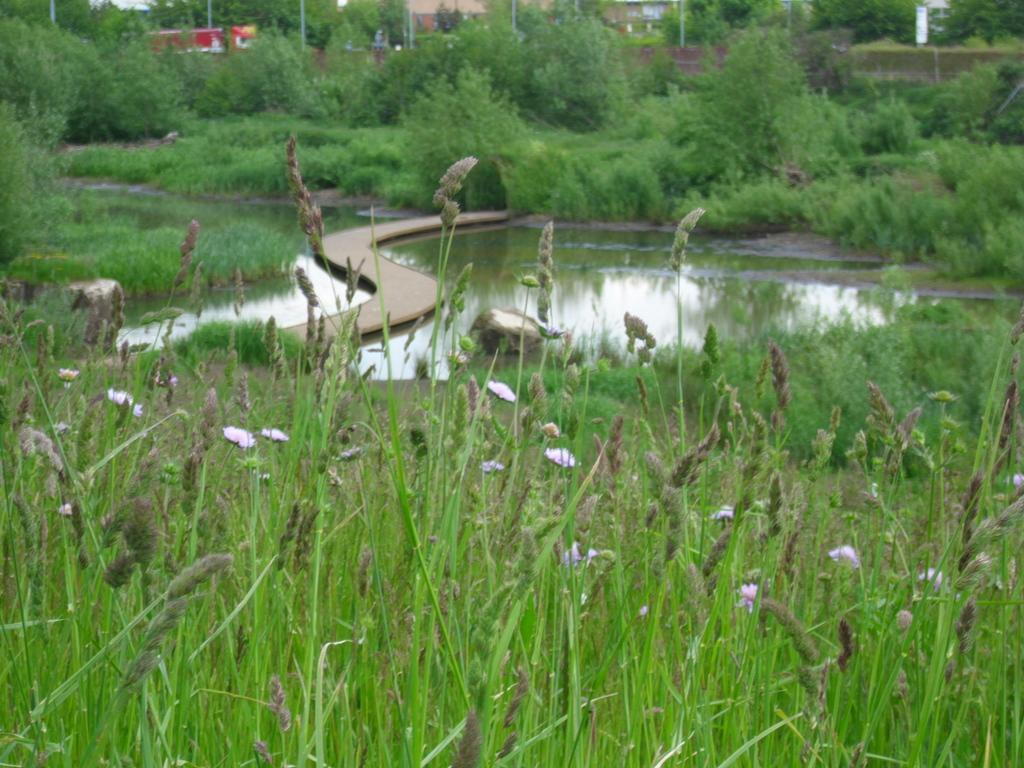What type of plants can be seen in the image? There are plants with flowers in the image. What type of vegetation is visible in the image? There is grass visible in the image. What natural element is present in the image? There is water in the image. What type of trees can be seen in the image? There are trees in the image. What type of structures are present in the image? There are buildings in the image. What else can be seen in the image besides plants, grass, water, trees, and buildings? There are poles and objects in the image. How does the disgusting smell affect the plants in the image? There is no mention of a disgusting smell in the image, so it cannot affect the plants. 